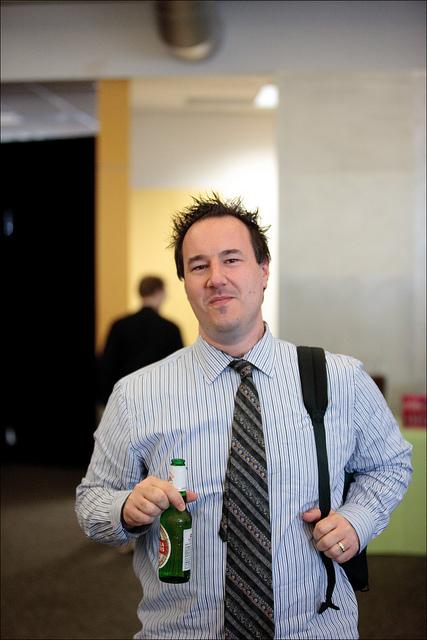Is this person wearing glasses?
Be succinct. No. Is the man wearing a belt?
Keep it brief. Yes. What pattern is his shirt?
Quick response, please. Striped. Are there shadows in this picture?
Keep it brief. Yes. See any pens?
Give a very brief answer. No. Whose tie is more colorful?
Quick response, please. His. What color is the tablecloth behind the man?
Write a very short answer. Green. Is the man getting dressed?
Concise answer only. No. Intelligent being holding an intelligent device?
Give a very brief answer. No. What floor is the elevator going to?
Answer briefly. 1. What is the man wearing?
Write a very short answer. Tie. Is the man wearing a funny hat?
Keep it brief. No. Does this man look comfortable?
Write a very short answer. Yes. What is the man drinking?
Keep it brief. Beer. What is the man eating?
Answer briefly. Beer. What is on the man's shoulder?
Give a very brief answer. Backpack. Shouldn't the man brush his hair?
Keep it brief. Yes. Does this man have sleeves on his shirt?
Write a very short answer. Yes. The action depicted in this image is called taking a what?
Answer briefly. Photo. What is the man holding?
Concise answer only. Beer. What color is the tote bag?
Short answer required. Black. Is the man carrying a bag?
Concise answer only. Yes. 